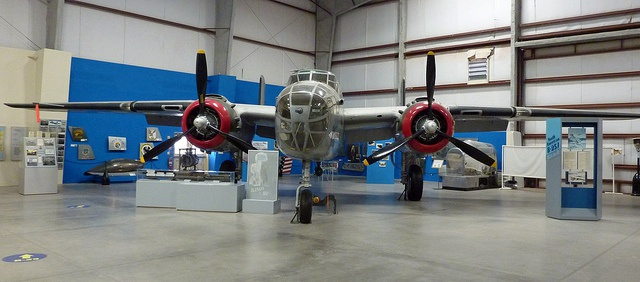Describe the objects in this image and their specific colors. I can see a airplane in darkgray, black, gray, and lightgray tones in this image. 